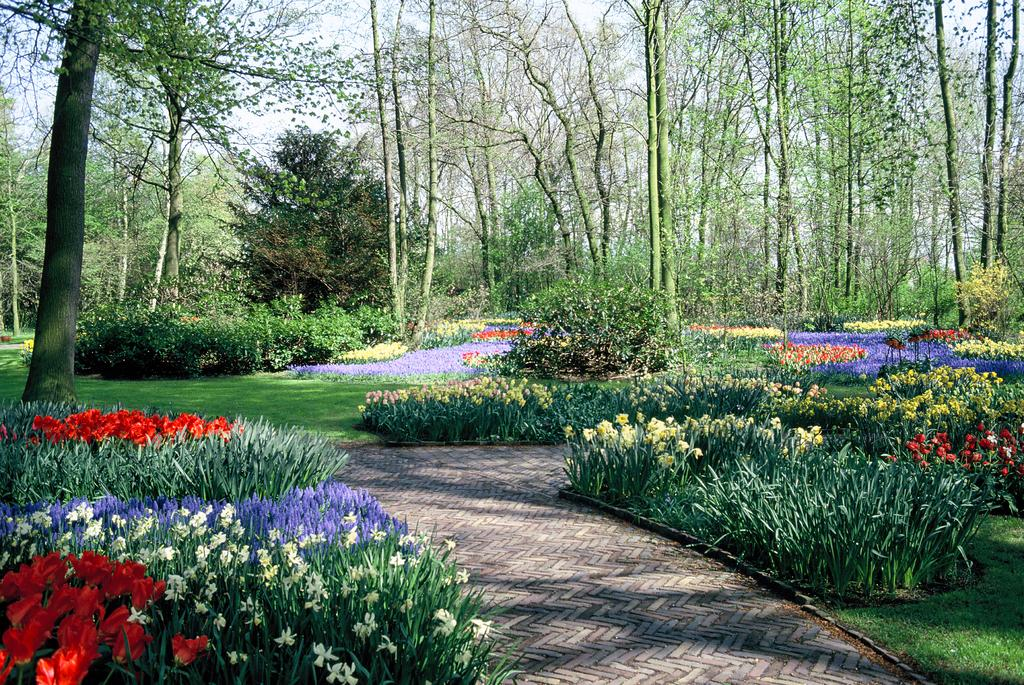What type of vegetation can be seen in the background of the image? There are trees in the background of the image. What other types of vegetation are present in the image? There are plants and grass in the image. What type of surface is in the center of the image? There is a pavement in the center of the image. What type of cheese is being used to create a chain in the image? There is no cheese or chain present in the image. 